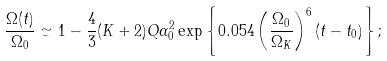<formula> <loc_0><loc_0><loc_500><loc_500>\frac { \Omega ( t ) } { \Omega _ { 0 } } \simeq 1 - \frac { 4 } { 3 } ( K + 2 ) Q \alpha _ { 0 } ^ { 2 } \exp \left \{ 0 . 0 5 4 \left ( \frac { \Omega _ { 0 } } { \Omega _ { K } } \right ) ^ { 6 } ( t - t _ { 0 } ) \right \} ;</formula> 